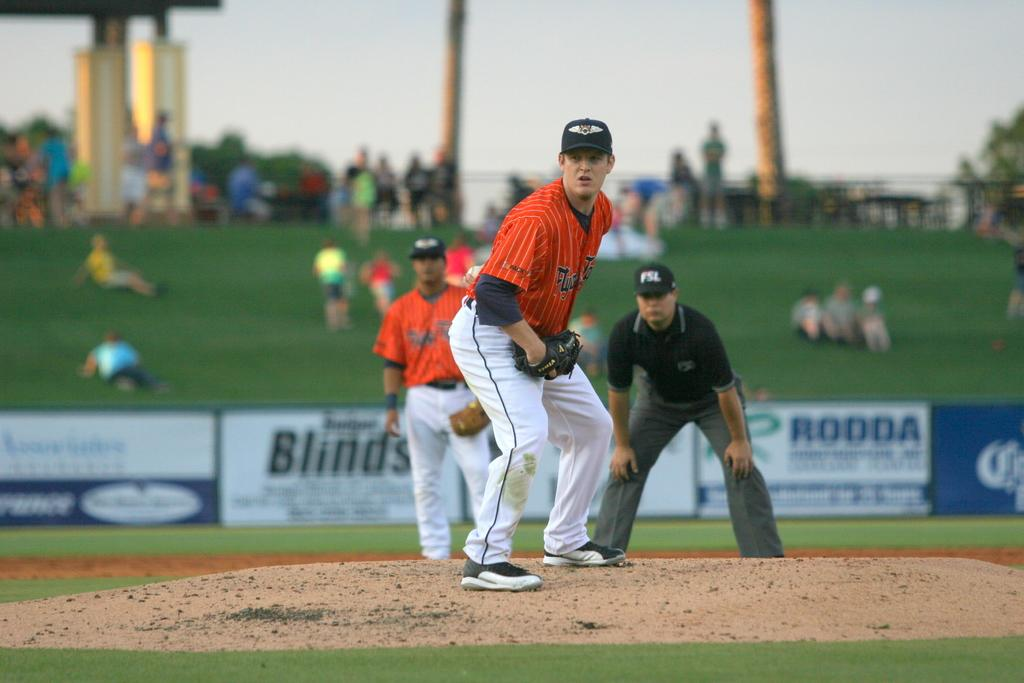<image>
Render a clear and concise summary of the photo. An ad for Rodda hangs at the back of the baseball field. 